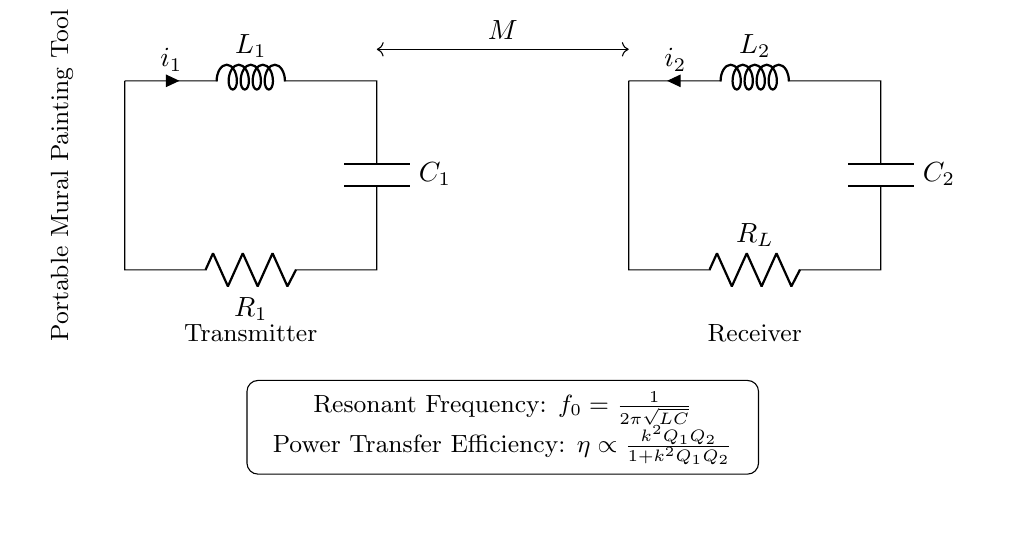What type of circuit is depicted? The circuit is an RLC resonant circuit, consisting of resistors, inductors, and capacitors. This is evident from the labeled components in the diagram.
Answer: RLC resonant circuit What are the impedance characteristics at resonance? At resonance, the impedance is minimized since the inductive and capacitive reactances cancel each other out, leaving only the resistive component. This results in maximum current flow.
Answer: Minimum impedance What do the labels L1 and L2 represent? L1 and L2 are symbols for inductors in the circuit. They are distinctly labeled on the diagram and serve as the coils in the wireless power transfer system.
Answer: Inductors What is the purpose of the coupling labeled M? Coupling M represents mutual inductance between the inductors L1 and L2, indicating how energy is transferred from the transmitter to the receiver. This is crucial for wireless energy transfer.
Answer: Mutual inductance What is the formula for resonant frequency? The formula indicated in the circuit diagram for the resonant frequency is f0 = 1/2π√(LC), which shows the relationship between resonance, inductance, and capacitance.
Answer: f0 = 1/2π√(LC) What does the variable Q represent in the power transfer efficiency equation? The variable Q represents the quality factor of the circuits, indicating how underdamped the oscillators are and their energy storage capability relative to energy loss. A higher Q results in higher efficiency.
Answer: Quality factor 